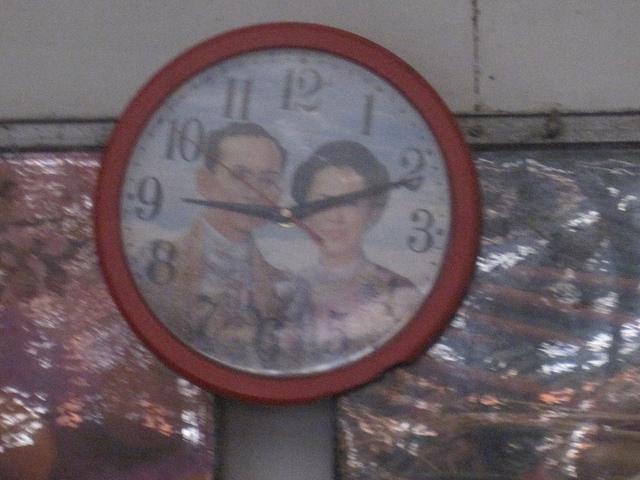How many people can you see?
Give a very brief answer. 2. 